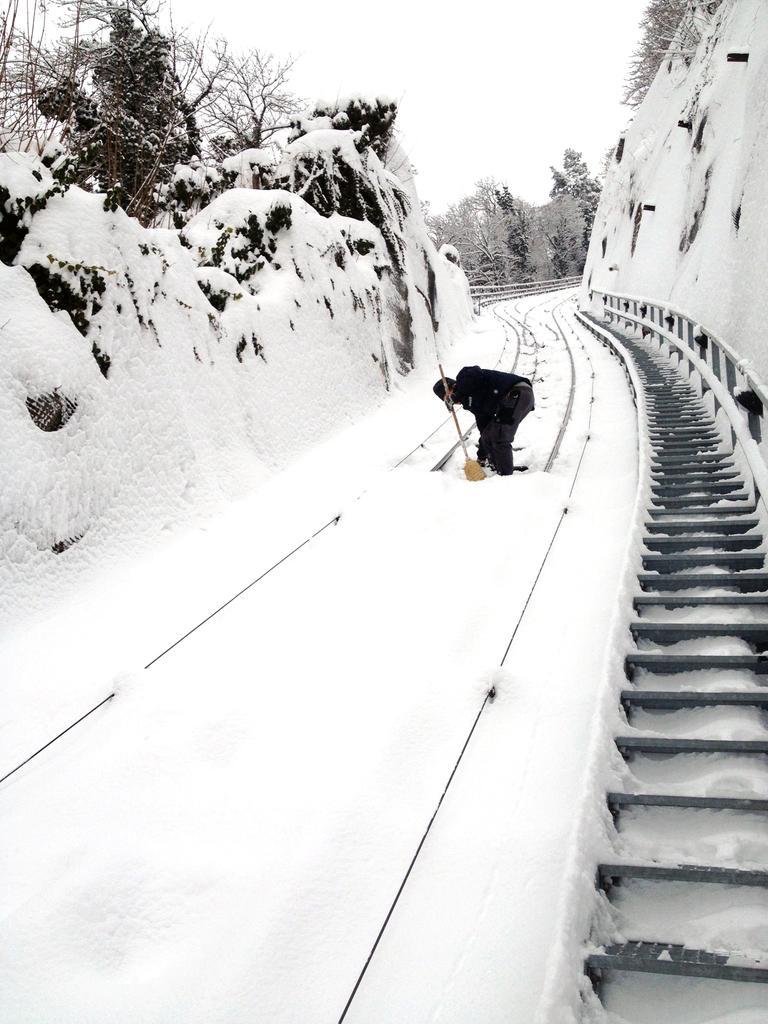Could you give a brief overview of what you see in this image? In this image there is a railway track. There is snow on the track. In the center there is a man standing on the track. To the right there are steps and a railing. On the either sides of the image there are mountains and trees. There is snow on the mountains. At the top there is the sky. 